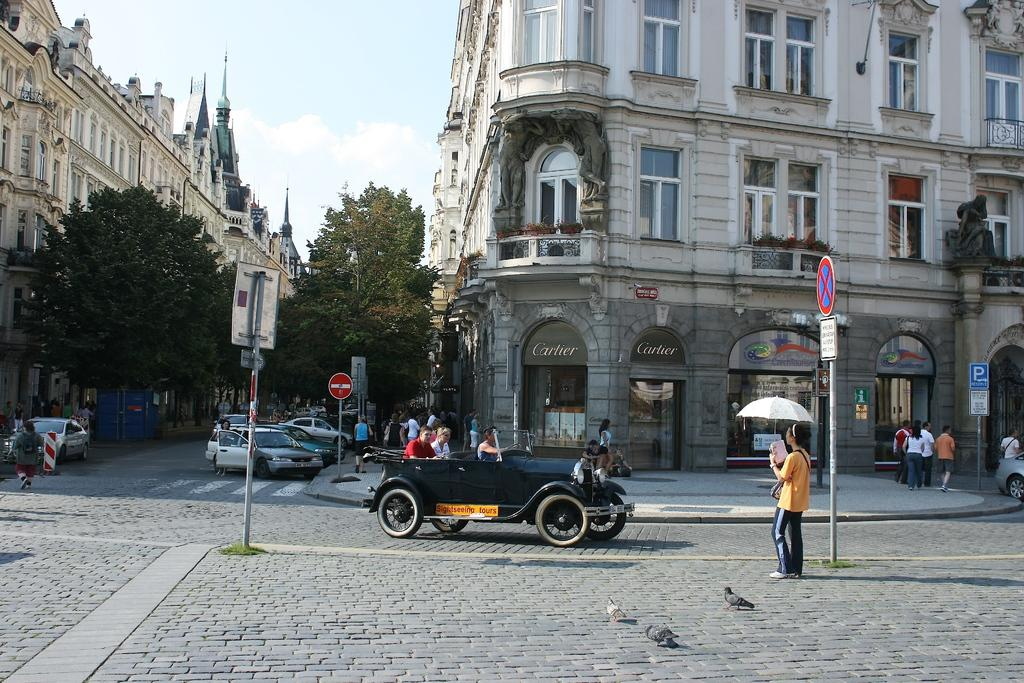What type of structures can be seen in the image? There are buildings in the image. What other natural elements are present in the image? There are trees in the image. What man-made objects can be seen in the image? Vehicles, poles, and boards are present in the image. Are there any living beings in the image? Yes, people are in the image. What architectural features can be observed on the buildings? Windows are visible in the image. What is visible in the background of the image? The sky is visible in the background of the image, with clouds present. What type of needle is being used by the person in the image? There is no needle present in the image. What color is the pencil being used by the person in the image? There is no pencil present in the image. 